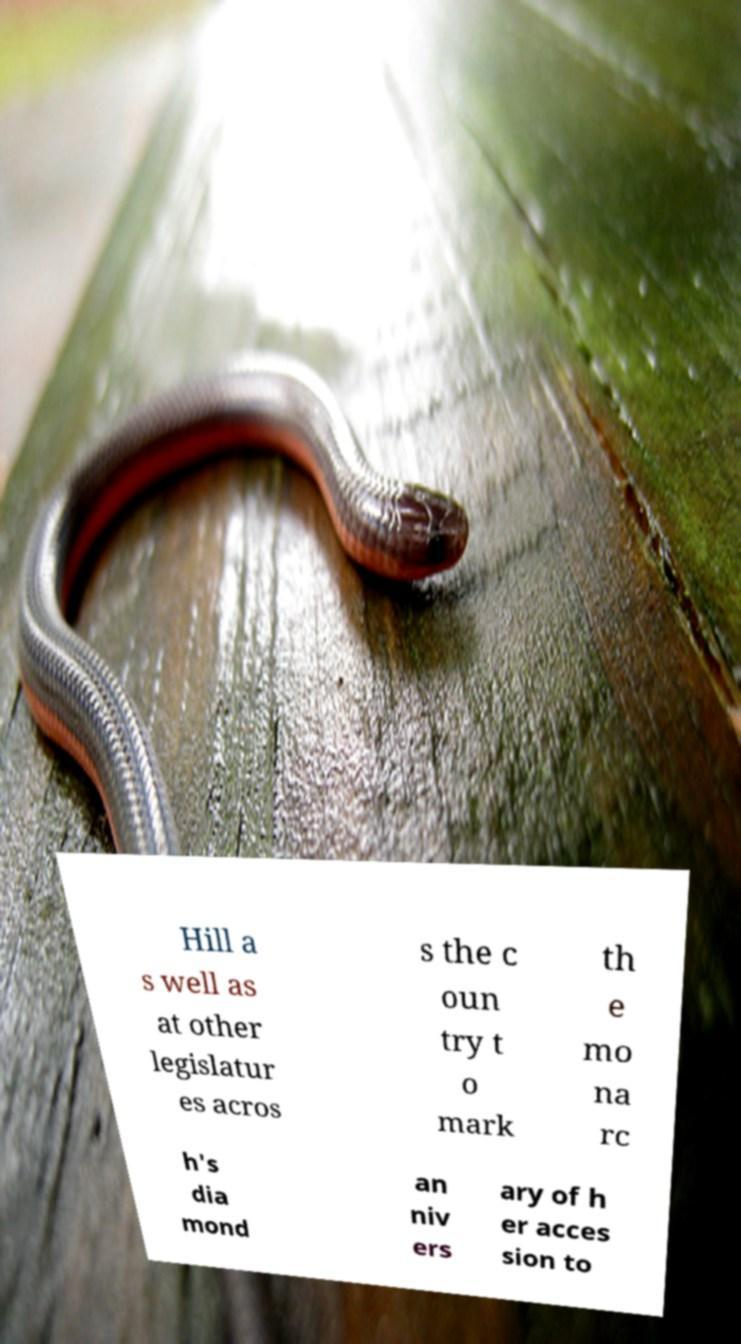Could you assist in decoding the text presented in this image and type it out clearly? Hill a s well as at other legislatur es acros s the c oun try t o mark th e mo na rc h's dia mond an niv ers ary of h er acces sion to 